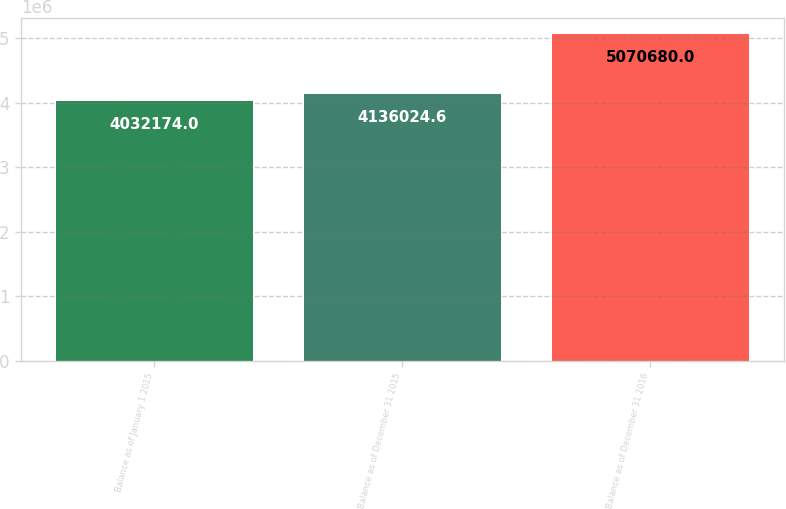Convert chart to OTSL. <chart><loc_0><loc_0><loc_500><loc_500><bar_chart><fcel>Balance as of January 1 2015<fcel>Balance as of December 31 2015<fcel>Balance as of December 31 2016<nl><fcel>4.03217e+06<fcel>4.13602e+06<fcel>5.07068e+06<nl></chart> 